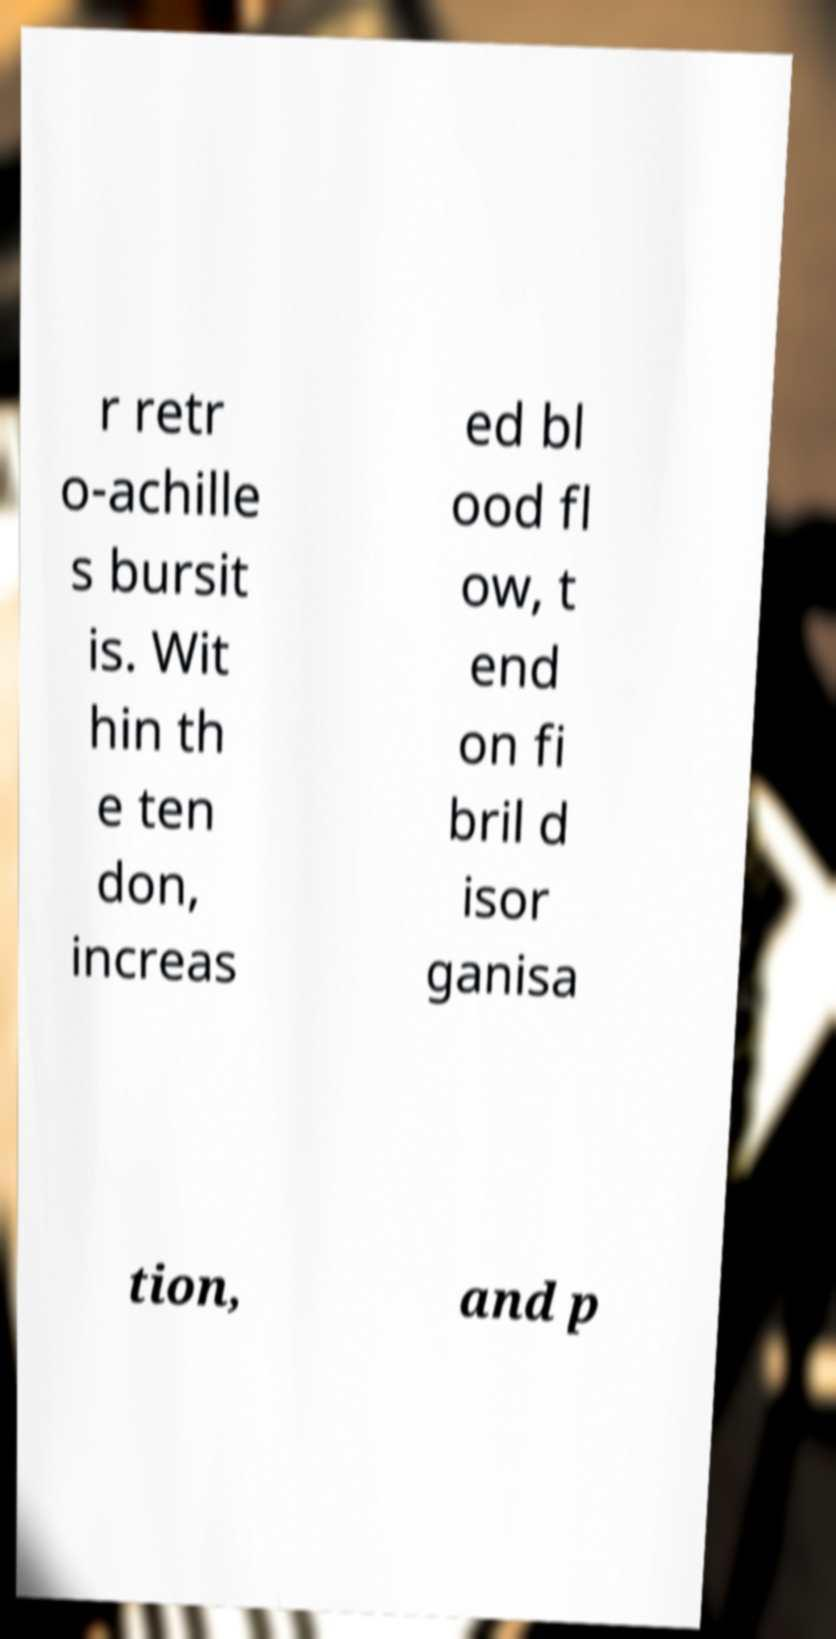Can you read and provide the text displayed in the image?This photo seems to have some interesting text. Can you extract and type it out for me? r retr o-achille s bursit is. Wit hin th e ten don, increas ed bl ood fl ow, t end on fi bril d isor ganisa tion, and p 